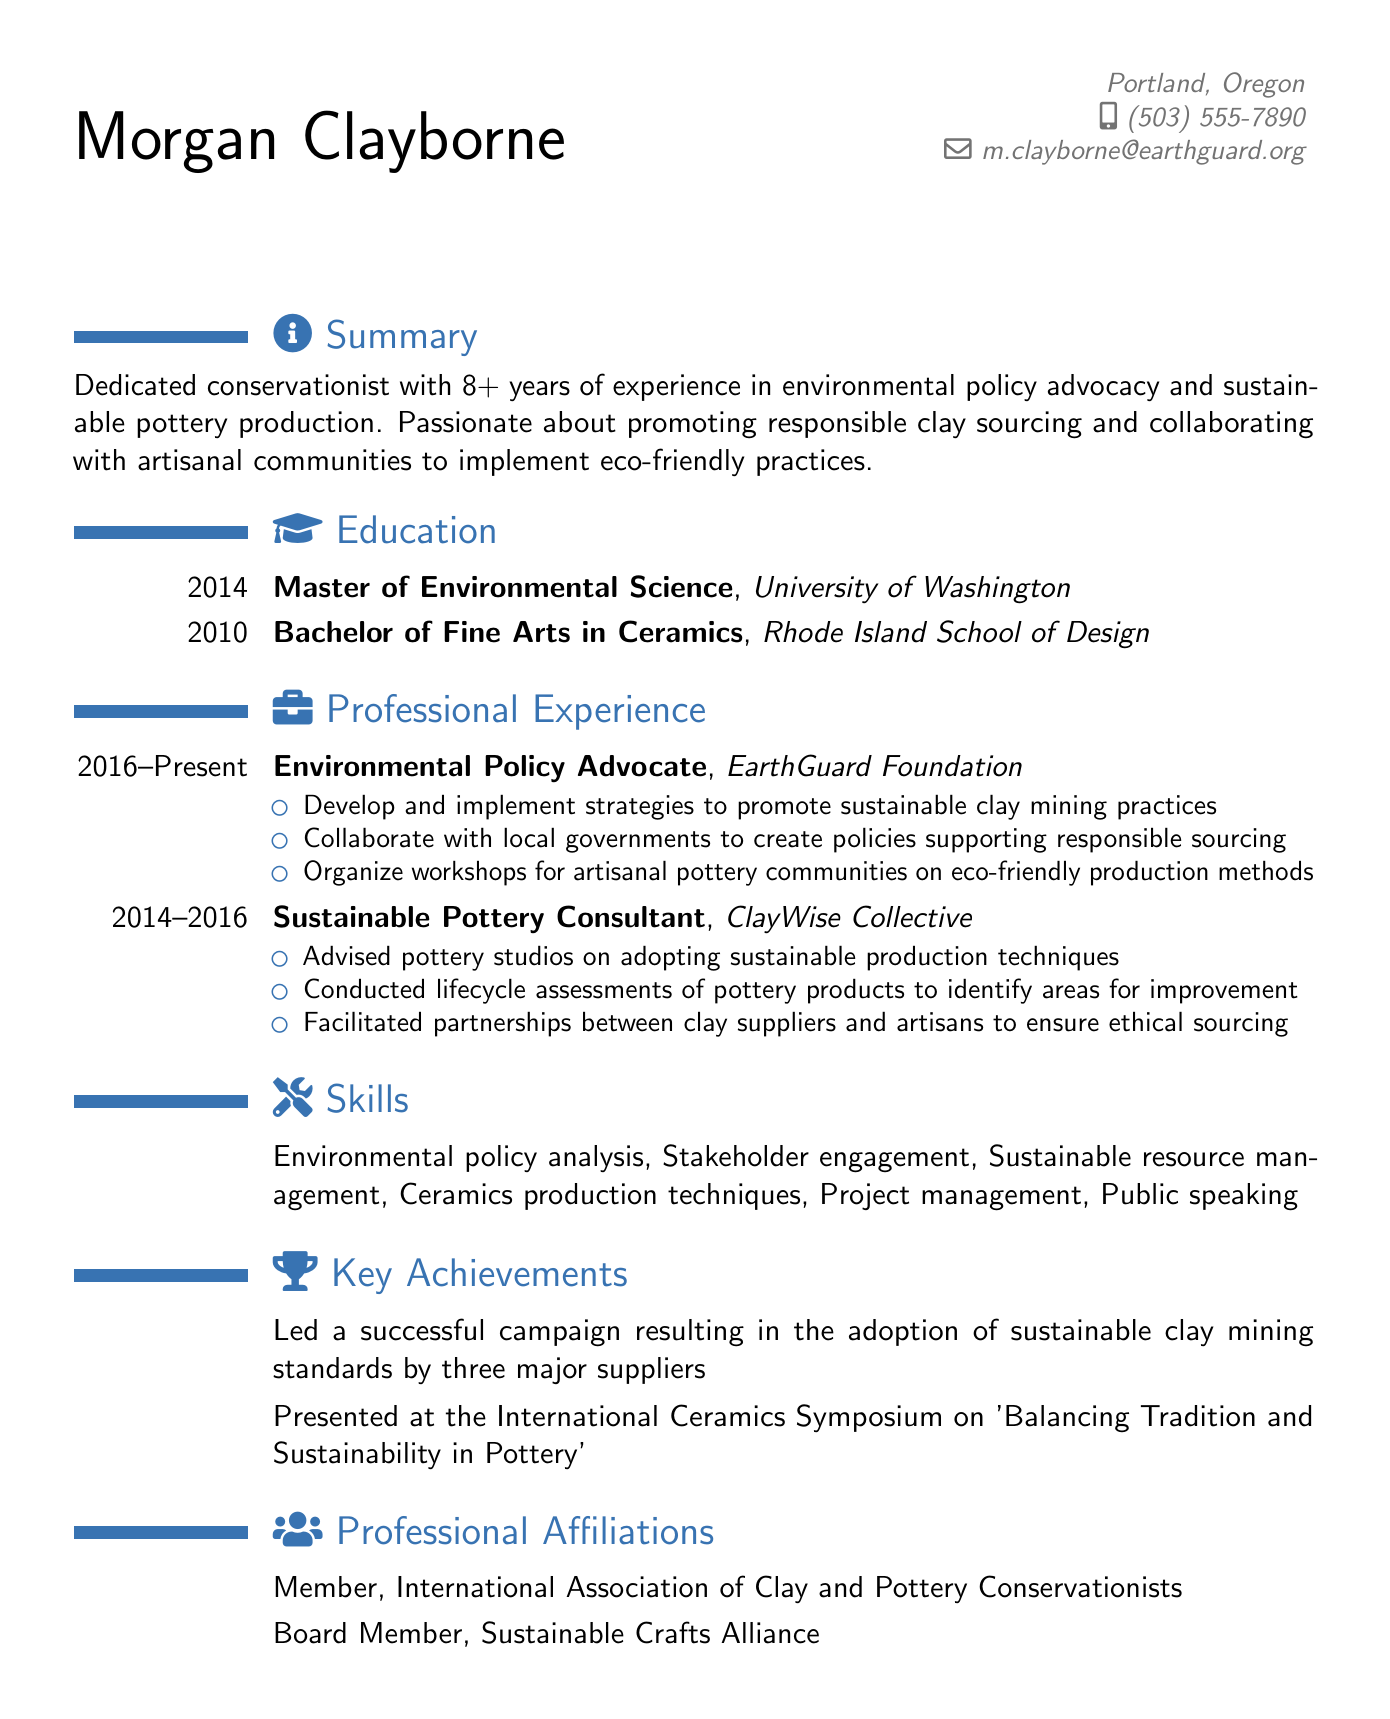What is the name of the individual? The document lists the individual's name as Morgan Clayborne.
Answer: Morgan Clayborne What is the primary focus of Morgan's professional experience? The summary highlights Morgan's dedication to environmental policy advocacy and sustainable pottery production.
Answer: Environmental policy advocacy In which year did Morgan complete the Master of Environmental Science? The education section specifies that Morgan completed this degree in 2014.
Answer: 2014 How many years of experience does Morgan have in the field? The summary indicates that Morgan has over 8 years of experience.
Answer: 8+ What title does Morgan hold at EarthGuard Foundation? Morgan is listed as an Environmental Policy Advocate in the professional experience section.
Answer: Environmental Policy Advocate List one of Morgan's key achievements. The achievements section includes leading a successful campaign for sustainable clay mining standards.
Answer: Adoption of sustainable clay mining standards What professional affiliation does Morgan hold? The document mentions membership in the International Association of Clay and Pottery Conservationists.
Answer: International Association of Clay and Pottery Conservationists During which years did Morgan work as a Sustainable Pottery Consultant? The professional experience specifies the years as 2014 to 2016.
Answer: 2014 - 2016 What educational background does Morgan have in Ceramics? The education section states that Morgan has a Bachelor of Fine Arts in Ceramics.
Answer: Bachelor of Fine Arts in Ceramics 